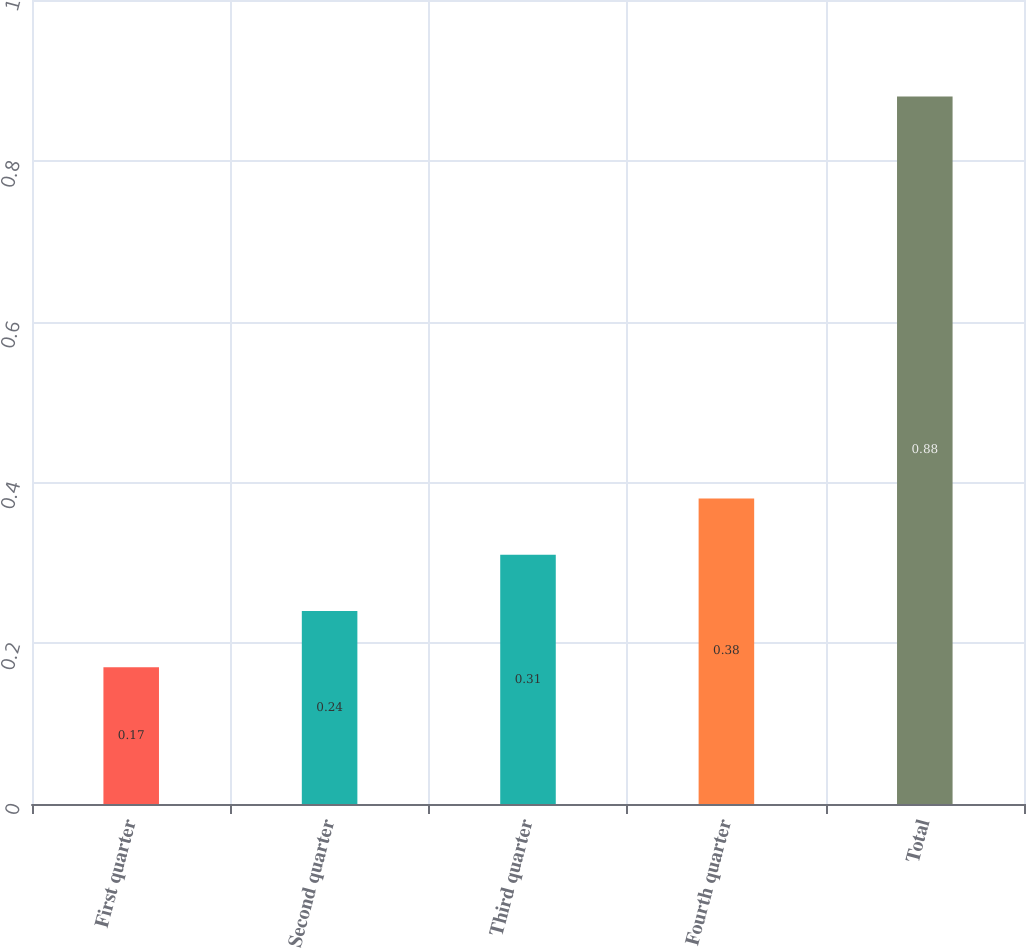<chart> <loc_0><loc_0><loc_500><loc_500><bar_chart><fcel>First quarter<fcel>Second quarter<fcel>Third quarter<fcel>Fourth quarter<fcel>Total<nl><fcel>0.17<fcel>0.24<fcel>0.31<fcel>0.38<fcel>0.88<nl></chart> 